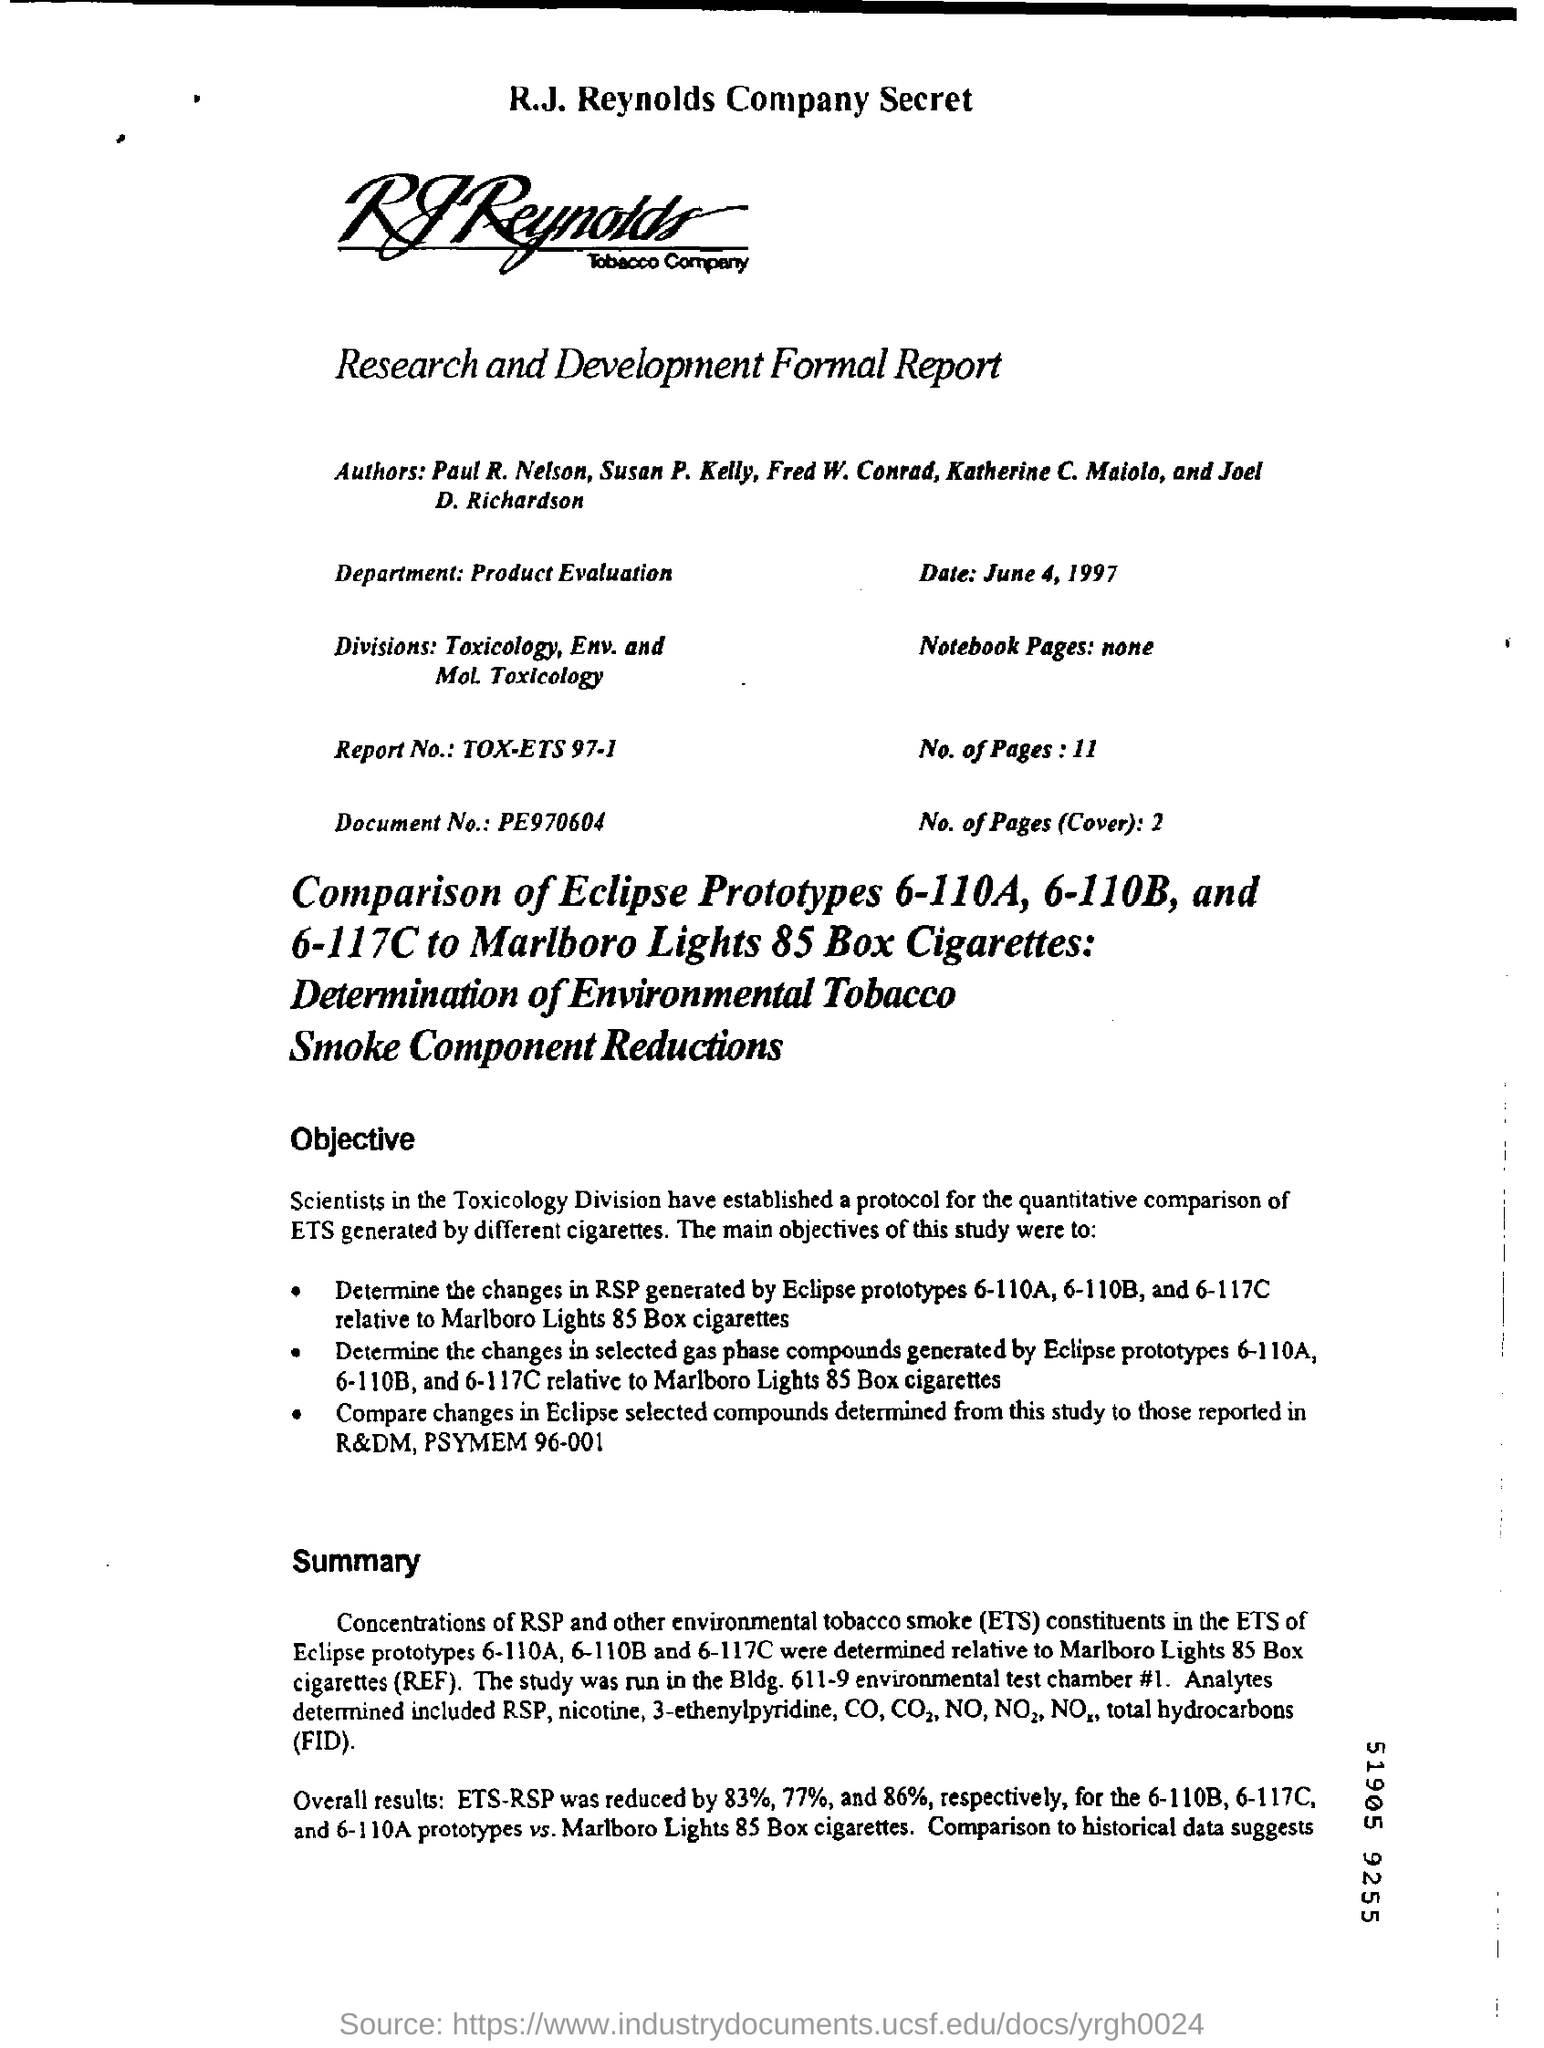What is the report no?
Your answer should be very brief. Tox-ets 97-1. What kind of department in the research and development formal report?
Make the answer very short. Product evaluation. What is the name of the division in the research and development formal report?
Make the answer very short. Toxicology, Env. and Mol. Toxicology. What is the date in the report?
Your response must be concise. June 4, 1997. What is the document number?
Your answer should be compact. PE970604. How many pages in the the report?
Keep it short and to the point. 11. 